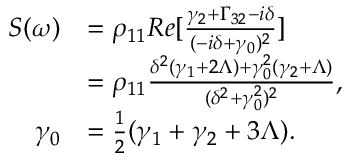Convert formula to latex. <formula><loc_0><loc_0><loc_500><loc_500>\begin{array} { r l } { S ( \omega ) } & { = \rho _ { 1 1 } R e [ \frac { \gamma _ { 2 } + \Gamma _ { 3 2 } - i \delta } { ( - i \delta + \gamma _ { 0 } ) ^ { 2 } } ] } \\ & { = \rho _ { 1 1 } \frac { \delta ^ { 2 } ( \gamma _ { 1 } + 2 \Lambda ) + \gamma _ { 0 } ^ { 2 } ( \gamma _ { 2 } + \Lambda ) } { ( \delta ^ { 2 } + \gamma _ { 0 } ^ { 2 } ) ^ { 2 } } , } \\ { \gamma _ { 0 } } & { = \frac { 1 } { 2 } ( \gamma _ { 1 } + \gamma _ { 2 } + 3 \Lambda ) . } \end{array}</formula> 